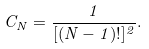Convert formula to latex. <formula><loc_0><loc_0><loc_500><loc_500>C _ { N } = \frac { 1 } { [ ( N - 1 ) ! ] ^ { 2 } } .</formula> 